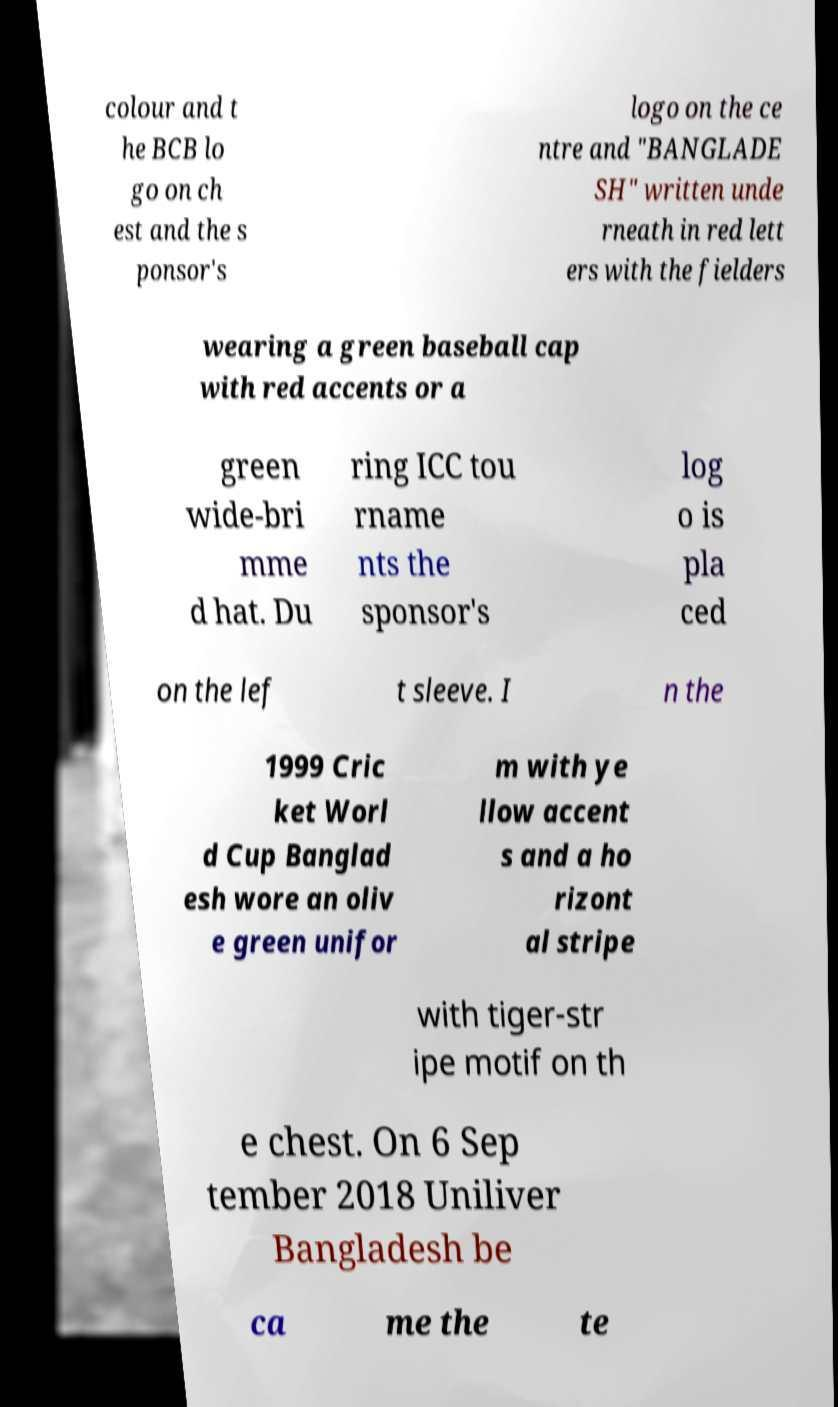Can you accurately transcribe the text from the provided image for me? colour and t he BCB lo go on ch est and the s ponsor's logo on the ce ntre and "BANGLADE SH" written unde rneath in red lett ers with the fielders wearing a green baseball cap with red accents or a green wide-bri mme d hat. Du ring ICC tou rname nts the sponsor's log o is pla ced on the lef t sleeve. I n the 1999 Cric ket Worl d Cup Banglad esh wore an oliv e green unifor m with ye llow accent s and a ho rizont al stripe with tiger-str ipe motif on th e chest. On 6 Sep tember 2018 Uniliver Bangladesh be ca me the te 